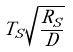Convert formula to latex. <formula><loc_0><loc_0><loc_500><loc_500>T _ { S } \sqrt { \frac { R _ { S } } { D } }</formula> 